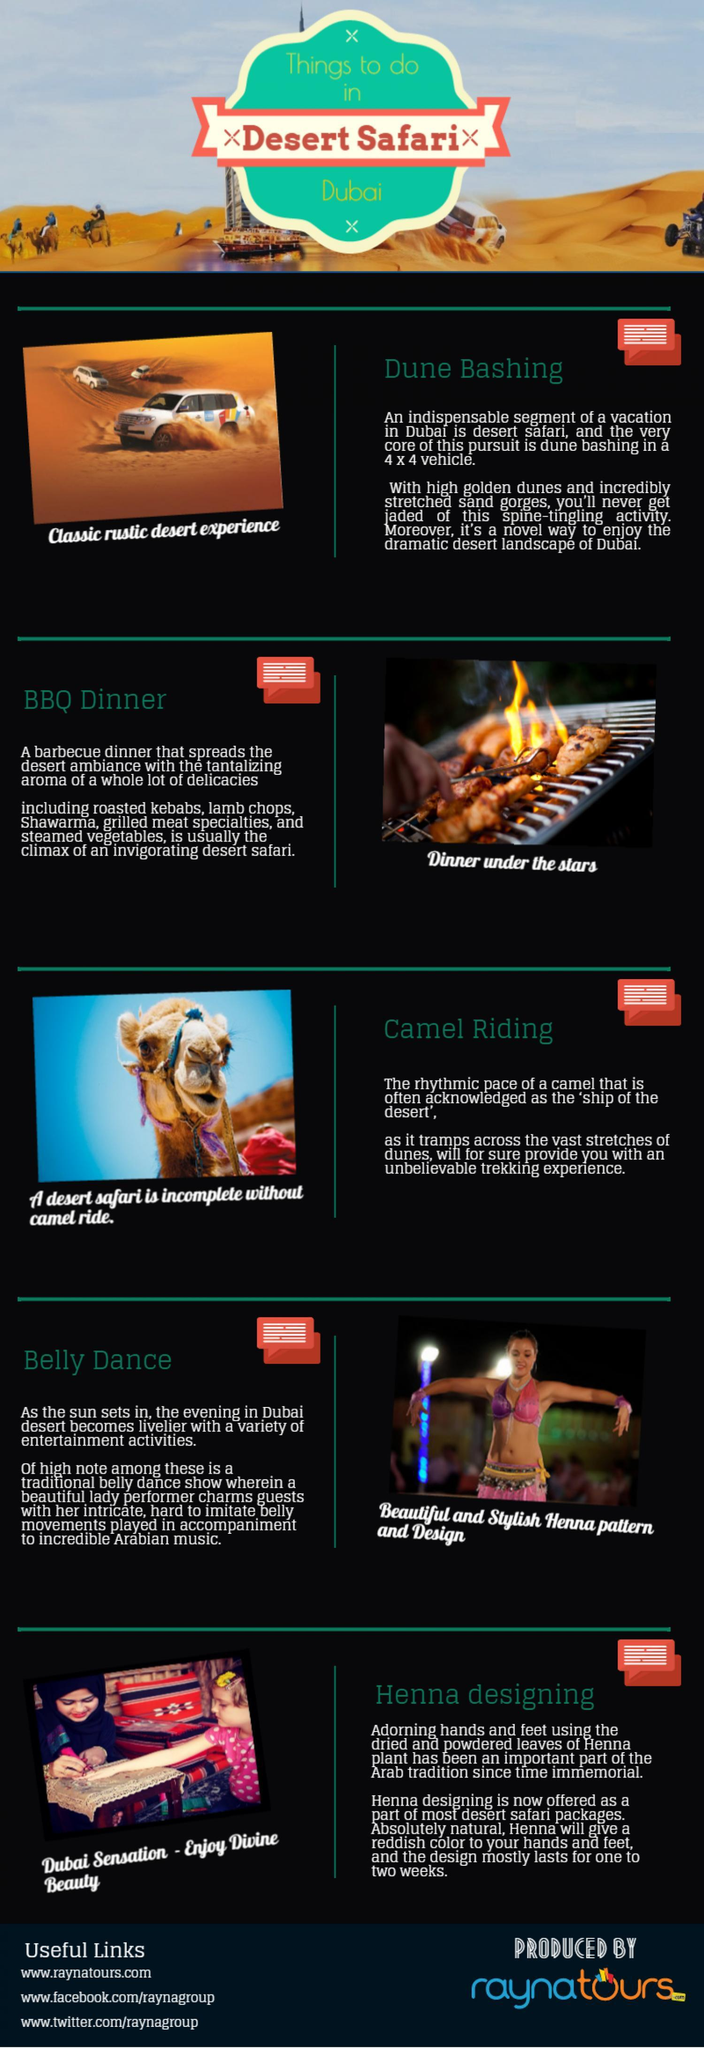What is the important segment of desert safari?
Answer the question with a short phrase. Dune Bashing Which thing is visualized in the fourth infographic? Belly Dance How many things to do on a desert safari in Dubai? 5 Which thing is visualized in the third infographic? Camel Riding 